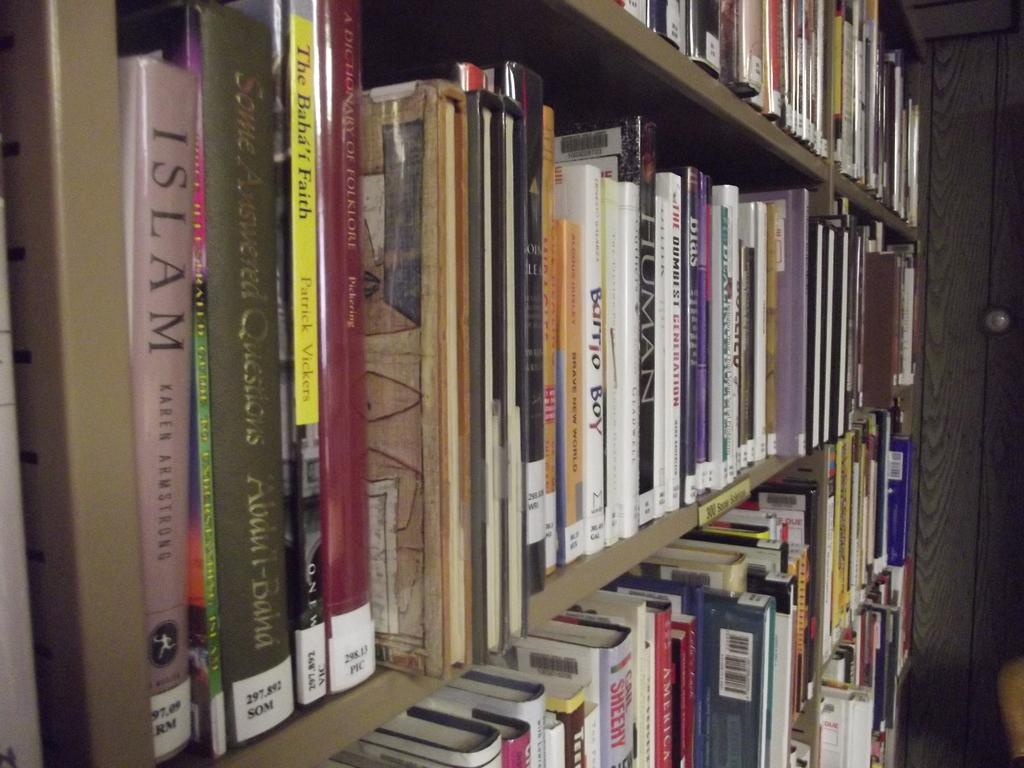<image>
Create a compact narrative representing the image presented. A shelf of books with one book titled ISLAM on the far end. 